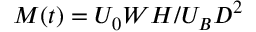Convert formula to latex. <formula><loc_0><loc_0><loc_500><loc_500>M ( t ) = U _ { 0 } W H / U _ { B } D ^ { 2 }</formula> 